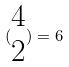<formula> <loc_0><loc_0><loc_500><loc_500>( \begin{matrix} 4 \\ 2 \end{matrix} ) = 6</formula> 